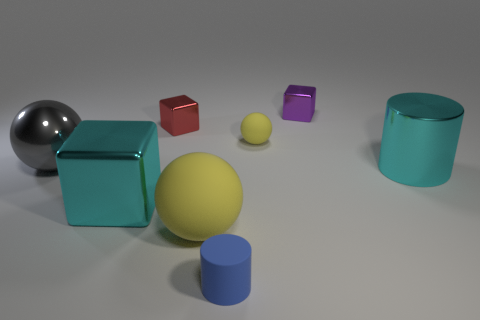There is a small thing that is the same color as the large matte thing; what is its material?
Your response must be concise. Rubber. How many things are cyan things right of the small purple metal object or small brown shiny balls?
Provide a short and direct response. 1. There is a big cyan object that is on the left side of the tiny metallic cube that is to the right of the small matte cylinder; what shape is it?
Your answer should be very brief. Cube. There is a rubber object behind the large yellow matte sphere; is it the same shape as the red shiny object?
Make the answer very short. No. What color is the large metallic thing that is on the right side of the red object?
Offer a very short reply. Cyan. What number of cubes are either tiny purple objects or big gray metal objects?
Provide a short and direct response. 1. How big is the cylinder that is on the right side of the small blue matte thing to the left of the tiny purple block?
Your response must be concise. Large. There is a large block; is it the same color as the small cube that is to the right of the tiny yellow matte sphere?
Ensure brevity in your answer.  No. How many big yellow spheres are behind the purple metallic thing?
Offer a terse response. 0. Are there fewer yellow rubber things than blue shiny blocks?
Keep it short and to the point. No. 